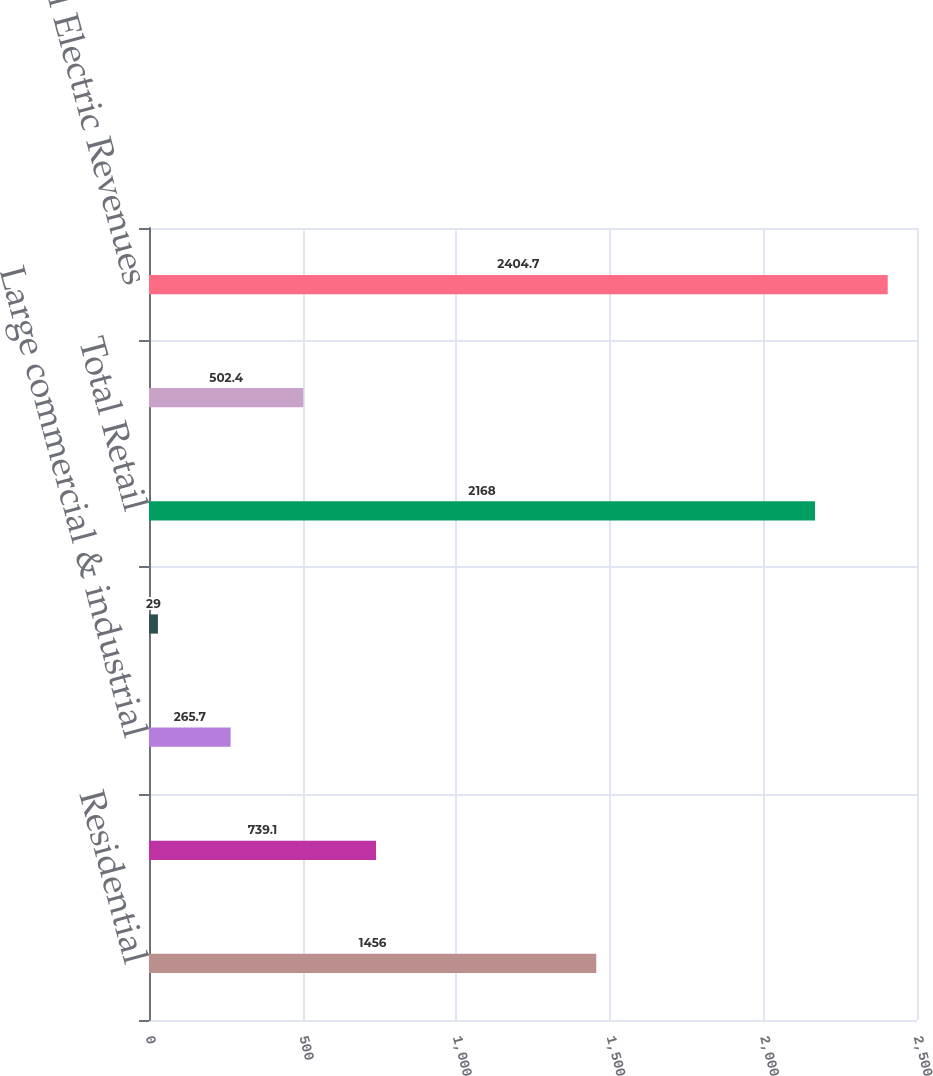<chart> <loc_0><loc_0><loc_500><loc_500><bar_chart><fcel>Residential<fcel>Small commercial & industrial<fcel>Large commercial & industrial<fcel>Public authorities & electric<fcel>Total Retail<fcel>Other Revenue (b)<fcel>Total Electric Revenues<nl><fcel>1456<fcel>739.1<fcel>265.7<fcel>29<fcel>2168<fcel>502.4<fcel>2404.7<nl></chart> 